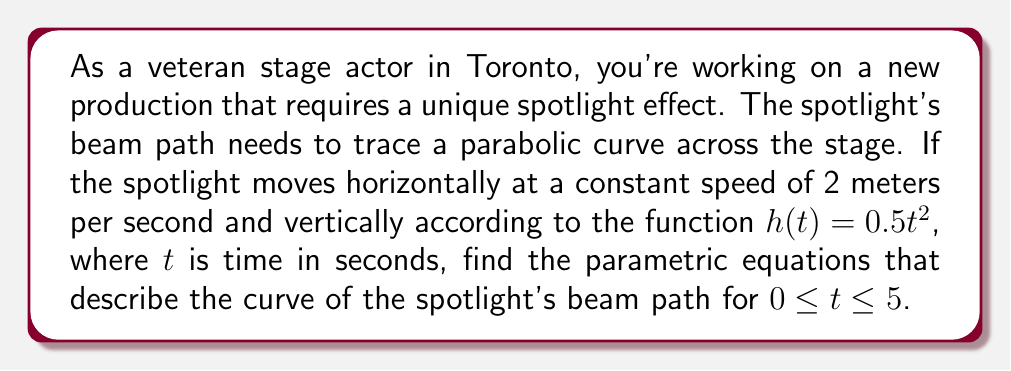Show me your answer to this math problem. To find the parametric equations for the spotlight's beam path, we need to express both the horizontal (x) and vertical (y) positions as functions of time (t).

1. Horizontal motion:
   The spotlight moves horizontally at a constant speed of 2 m/s.
   Distance = Speed × Time
   $x(t) = 2t$

2. Vertical motion:
   The vertical position is given by the function $h(t) = 0.5t^2$
   $y(t) = 0.5t^2$

3. Parametric equations:
   Combining the horizontal and vertical motions, we get:
   $x(t) = 2t$
   $y(t) = 0.5t^2$

4. Time interval:
   The question specifies $0 \leq t \leq 5$

Therefore, the parametric equations describing the curve of the spotlight's beam path are:

$$\begin{cases}
x(t) = 2t \\
y(t) = 0.5t^2
\end{cases}, \quad 0 \leq t \leq 5$$

This represents a parabolic curve on the stage, with the spotlight starting at the origin (0,0) when $t=0$ and ending at the point (10,12.5) when $t=5$.
Answer: $x(t) = 2t$, $y(t) = 0.5t^2$, $0 \leq t \leq 5$ 